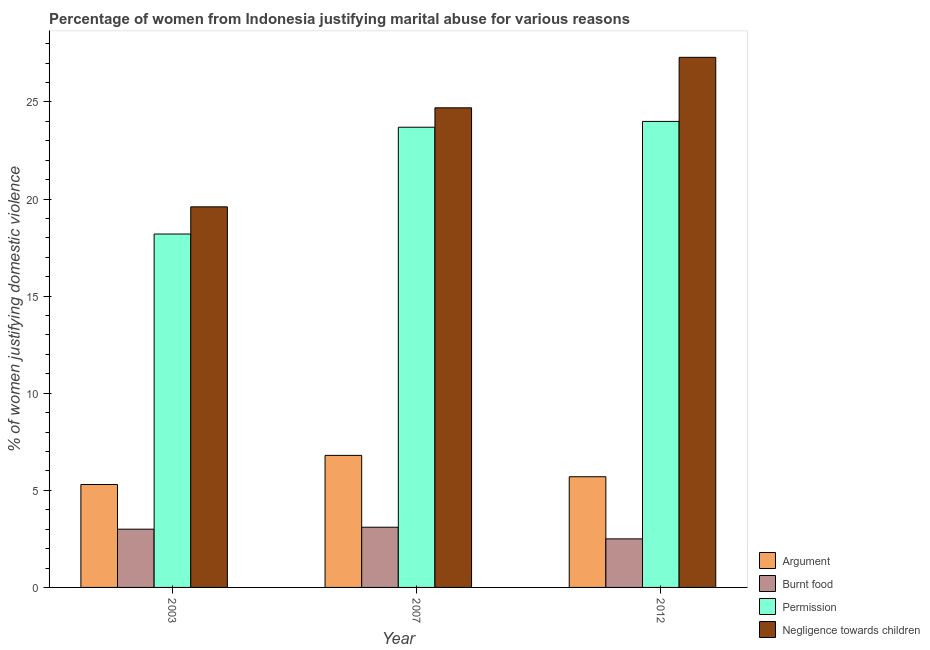How many different coloured bars are there?
Make the answer very short. 4. How many groups of bars are there?
Your response must be concise. 3. Are the number of bars per tick equal to the number of legend labels?
Your response must be concise. Yes. Are the number of bars on each tick of the X-axis equal?
Your answer should be compact. Yes. How many bars are there on the 1st tick from the left?
Your answer should be very brief. 4. What is the label of the 2nd group of bars from the left?
Provide a short and direct response. 2007. In how many cases, is the number of bars for a given year not equal to the number of legend labels?
Keep it short and to the point. 0. What is the percentage of women justifying abuse for showing negligence towards children in 2012?
Your answer should be compact. 27.3. Across all years, what is the minimum percentage of women justifying abuse for showing negligence towards children?
Provide a short and direct response. 19.6. In which year was the percentage of women justifying abuse for showing negligence towards children maximum?
Give a very brief answer. 2012. What is the difference between the percentage of women justifying abuse in the case of an argument in 2003 and that in 2012?
Give a very brief answer. -0.4. What is the difference between the percentage of women justifying abuse for showing negligence towards children in 2012 and the percentage of women justifying abuse for going without permission in 2003?
Provide a short and direct response. 7.7. What is the average percentage of women justifying abuse for going without permission per year?
Give a very brief answer. 21.97. In how many years, is the percentage of women justifying abuse in the case of an argument greater than 3 %?
Your response must be concise. 3. What is the ratio of the percentage of women justifying abuse for going without permission in 2003 to that in 2012?
Offer a very short reply. 0.76. Is the percentage of women justifying abuse in the case of an argument in 2003 less than that in 2007?
Offer a terse response. Yes. What is the difference between the highest and the second highest percentage of women justifying abuse for going without permission?
Ensure brevity in your answer.  0.3. What is the difference between the highest and the lowest percentage of women justifying abuse in the case of an argument?
Keep it short and to the point. 1.5. What does the 3rd bar from the left in 2007 represents?
Ensure brevity in your answer.  Permission. What does the 3rd bar from the right in 2012 represents?
Make the answer very short. Burnt food. Is it the case that in every year, the sum of the percentage of women justifying abuse in the case of an argument and percentage of women justifying abuse for burning food is greater than the percentage of women justifying abuse for going without permission?
Your answer should be compact. No. How many bars are there?
Offer a terse response. 12. Are the values on the major ticks of Y-axis written in scientific E-notation?
Provide a short and direct response. No. Does the graph contain grids?
Your answer should be compact. No. How are the legend labels stacked?
Ensure brevity in your answer.  Vertical. What is the title of the graph?
Offer a terse response. Percentage of women from Indonesia justifying marital abuse for various reasons. What is the label or title of the Y-axis?
Make the answer very short. % of women justifying domestic violence. What is the % of women justifying domestic violence in Negligence towards children in 2003?
Ensure brevity in your answer.  19.6. What is the % of women justifying domestic violence of Permission in 2007?
Make the answer very short. 23.7. What is the % of women justifying domestic violence of Negligence towards children in 2007?
Provide a succinct answer. 24.7. What is the % of women justifying domestic violence of Permission in 2012?
Keep it short and to the point. 24. What is the % of women justifying domestic violence of Negligence towards children in 2012?
Offer a very short reply. 27.3. Across all years, what is the maximum % of women justifying domestic violence in Burnt food?
Your response must be concise. 3.1. Across all years, what is the maximum % of women justifying domestic violence in Negligence towards children?
Offer a terse response. 27.3. Across all years, what is the minimum % of women justifying domestic violence of Argument?
Provide a succinct answer. 5.3. Across all years, what is the minimum % of women justifying domestic violence of Burnt food?
Your answer should be very brief. 2.5. Across all years, what is the minimum % of women justifying domestic violence in Permission?
Provide a short and direct response. 18.2. Across all years, what is the minimum % of women justifying domestic violence of Negligence towards children?
Keep it short and to the point. 19.6. What is the total % of women justifying domestic violence in Burnt food in the graph?
Offer a terse response. 8.6. What is the total % of women justifying domestic violence of Permission in the graph?
Your answer should be very brief. 65.9. What is the total % of women justifying domestic violence in Negligence towards children in the graph?
Your answer should be compact. 71.6. What is the difference between the % of women justifying domestic violence in Negligence towards children in 2003 and that in 2007?
Keep it short and to the point. -5.1. What is the difference between the % of women justifying domestic violence of Negligence towards children in 2003 and that in 2012?
Offer a very short reply. -7.7. What is the difference between the % of women justifying domestic violence of Argument in 2003 and the % of women justifying domestic violence of Burnt food in 2007?
Keep it short and to the point. 2.2. What is the difference between the % of women justifying domestic violence in Argument in 2003 and the % of women justifying domestic violence in Permission in 2007?
Make the answer very short. -18.4. What is the difference between the % of women justifying domestic violence of Argument in 2003 and the % of women justifying domestic violence of Negligence towards children in 2007?
Your answer should be compact. -19.4. What is the difference between the % of women justifying domestic violence in Burnt food in 2003 and the % of women justifying domestic violence in Permission in 2007?
Give a very brief answer. -20.7. What is the difference between the % of women justifying domestic violence of Burnt food in 2003 and the % of women justifying domestic violence of Negligence towards children in 2007?
Provide a succinct answer. -21.7. What is the difference between the % of women justifying domestic violence in Permission in 2003 and the % of women justifying domestic violence in Negligence towards children in 2007?
Your answer should be compact. -6.5. What is the difference between the % of women justifying domestic violence of Argument in 2003 and the % of women justifying domestic violence of Burnt food in 2012?
Make the answer very short. 2.8. What is the difference between the % of women justifying domestic violence in Argument in 2003 and the % of women justifying domestic violence in Permission in 2012?
Your answer should be compact. -18.7. What is the difference between the % of women justifying domestic violence in Argument in 2003 and the % of women justifying domestic violence in Negligence towards children in 2012?
Keep it short and to the point. -22. What is the difference between the % of women justifying domestic violence in Burnt food in 2003 and the % of women justifying domestic violence in Permission in 2012?
Ensure brevity in your answer.  -21. What is the difference between the % of women justifying domestic violence in Burnt food in 2003 and the % of women justifying domestic violence in Negligence towards children in 2012?
Make the answer very short. -24.3. What is the difference between the % of women justifying domestic violence in Argument in 2007 and the % of women justifying domestic violence in Burnt food in 2012?
Provide a succinct answer. 4.3. What is the difference between the % of women justifying domestic violence in Argument in 2007 and the % of women justifying domestic violence in Permission in 2012?
Your answer should be compact. -17.2. What is the difference between the % of women justifying domestic violence of Argument in 2007 and the % of women justifying domestic violence of Negligence towards children in 2012?
Offer a very short reply. -20.5. What is the difference between the % of women justifying domestic violence of Burnt food in 2007 and the % of women justifying domestic violence of Permission in 2012?
Provide a succinct answer. -20.9. What is the difference between the % of women justifying domestic violence in Burnt food in 2007 and the % of women justifying domestic violence in Negligence towards children in 2012?
Ensure brevity in your answer.  -24.2. What is the difference between the % of women justifying domestic violence in Permission in 2007 and the % of women justifying domestic violence in Negligence towards children in 2012?
Give a very brief answer. -3.6. What is the average % of women justifying domestic violence of Argument per year?
Offer a terse response. 5.93. What is the average % of women justifying domestic violence of Burnt food per year?
Your answer should be very brief. 2.87. What is the average % of women justifying domestic violence of Permission per year?
Offer a terse response. 21.97. What is the average % of women justifying domestic violence in Negligence towards children per year?
Make the answer very short. 23.87. In the year 2003, what is the difference between the % of women justifying domestic violence of Argument and % of women justifying domestic violence of Burnt food?
Offer a very short reply. 2.3. In the year 2003, what is the difference between the % of women justifying domestic violence of Argument and % of women justifying domestic violence of Permission?
Provide a succinct answer. -12.9. In the year 2003, what is the difference between the % of women justifying domestic violence of Argument and % of women justifying domestic violence of Negligence towards children?
Provide a short and direct response. -14.3. In the year 2003, what is the difference between the % of women justifying domestic violence of Burnt food and % of women justifying domestic violence of Permission?
Give a very brief answer. -15.2. In the year 2003, what is the difference between the % of women justifying domestic violence of Burnt food and % of women justifying domestic violence of Negligence towards children?
Give a very brief answer. -16.6. In the year 2007, what is the difference between the % of women justifying domestic violence in Argument and % of women justifying domestic violence in Permission?
Your response must be concise. -16.9. In the year 2007, what is the difference between the % of women justifying domestic violence in Argument and % of women justifying domestic violence in Negligence towards children?
Offer a very short reply. -17.9. In the year 2007, what is the difference between the % of women justifying domestic violence of Burnt food and % of women justifying domestic violence of Permission?
Provide a short and direct response. -20.6. In the year 2007, what is the difference between the % of women justifying domestic violence of Burnt food and % of women justifying domestic violence of Negligence towards children?
Your answer should be very brief. -21.6. In the year 2007, what is the difference between the % of women justifying domestic violence of Permission and % of women justifying domestic violence of Negligence towards children?
Offer a terse response. -1. In the year 2012, what is the difference between the % of women justifying domestic violence in Argument and % of women justifying domestic violence in Burnt food?
Ensure brevity in your answer.  3.2. In the year 2012, what is the difference between the % of women justifying domestic violence of Argument and % of women justifying domestic violence of Permission?
Your response must be concise. -18.3. In the year 2012, what is the difference between the % of women justifying domestic violence of Argument and % of women justifying domestic violence of Negligence towards children?
Make the answer very short. -21.6. In the year 2012, what is the difference between the % of women justifying domestic violence in Burnt food and % of women justifying domestic violence in Permission?
Keep it short and to the point. -21.5. In the year 2012, what is the difference between the % of women justifying domestic violence of Burnt food and % of women justifying domestic violence of Negligence towards children?
Provide a succinct answer. -24.8. What is the ratio of the % of women justifying domestic violence of Argument in 2003 to that in 2007?
Provide a succinct answer. 0.78. What is the ratio of the % of women justifying domestic violence of Permission in 2003 to that in 2007?
Offer a very short reply. 0.77. What is the ratio of the % of women justifying domestic violence of Negligence towards children in 2003 to that in 2007?
Provide a short and direct response. 0.79. What is the ratio of the % of women justifying domestic violence of Argument in 2003 to that in 2012?
Your response must be concise. 0.93. What is the ratio of the % of women justifying domestic violence of Permission in 2003 to that in 2012?
Offer a terse response. 0.76. What is the ratio of the % of women justifying domestic violence in Negligence towards children in 2003 to that in 2012?
Give a very brief answer. 0.72. What is the ratio of the % of women justifying domestic violence in Argument in 2007 to that in 2012?
Provide a succinct answer. 1.19. What is the ratio of the % of women justifying domestic violence in Burnt food in 2007 to that in 2012?
Give a very brief answer. 1.24. What is the ratio of the % of women justifying domestic violence of Permission in 2007 to that in 2012?
Keep it short and to the point. 0.99. What is the ratio of the % of women justifying domestic violence of Negligence towards children in 2007 to that in 2012?
Provide a succinct answer. 0.9. What is the difference between the highest and the second highest % of women justifying domestic violence of Argument?
Give a very brief answer. 1.1. What is the difference between the highest and the second highest % of women justifying domestic violence in Burnt food?
Provide a succinct answer. 0.1. What is the difference between the highest and the second highest % of women justifying domestic violence of Negligence towards children?
Make the answer very short. 2.6. What is the difference between the highest and the lowest % of women justifying domestic violence of Burnt food?
Offer a terse response. 0.6. 